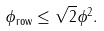<formula> <loc_0><loc_0><loc_500><loc_500>\| \phi \| _ { \text {row} } \leq \sqrt { 2 } \| \phi \| ^ { 2 } .</formula> 